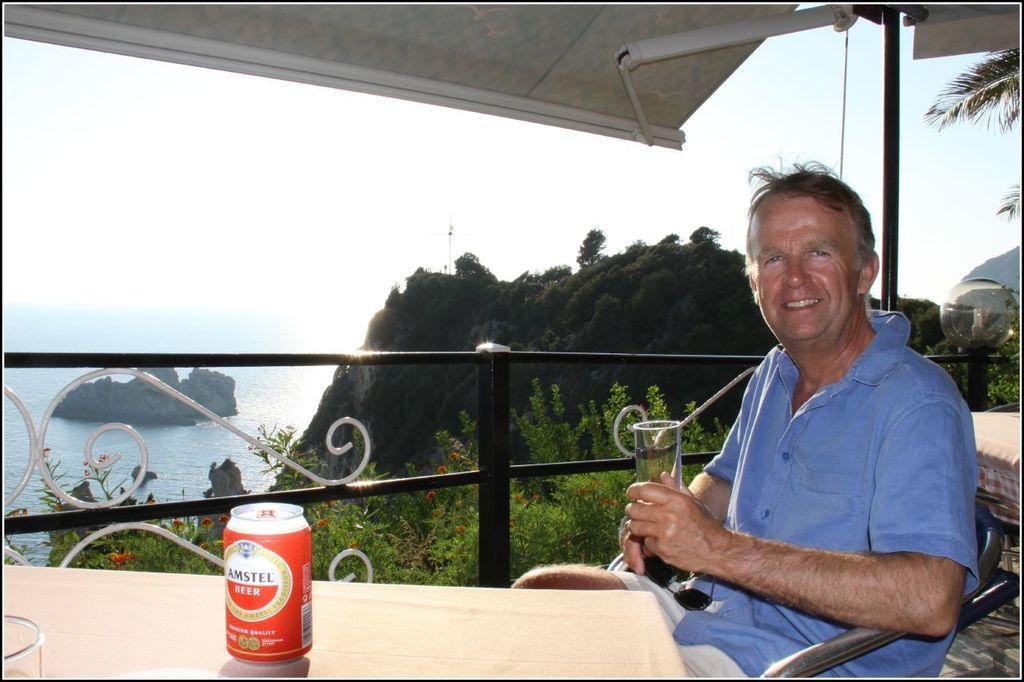Can you describe this image briefly? In this picture we can see a man sitting on the chair and holding a glass in his hand. We can see a spectacle on his lap. There is a beer bottle and a glass on the table. We can see some fencing from left to right. There are few plants and trees. We can see water on the left side. 